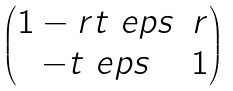Convert formula to latex. <formula><loc_0><loc_0><loc_500><loc_500>\begin{pmatrix} 1 - r t \ e p s & r \\ - t \ e p s & 1 \end{pmatrix}</formula> 